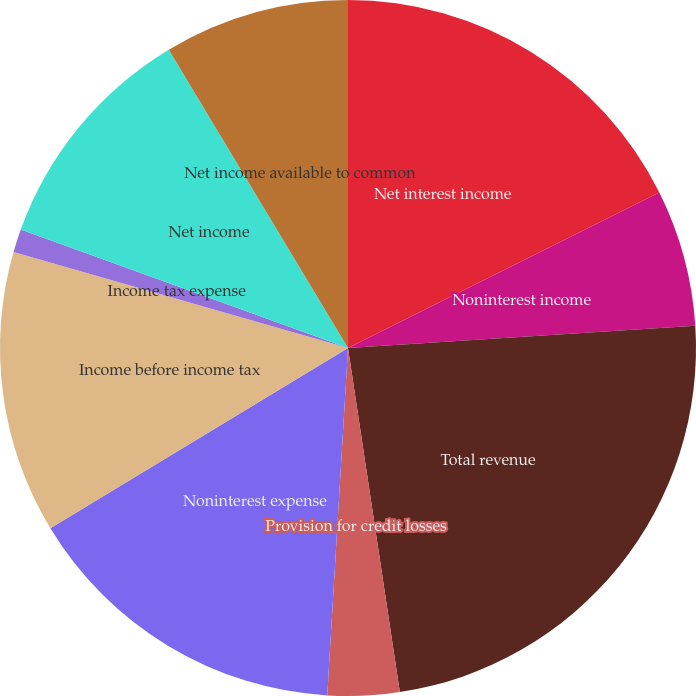<chart> <loc_0><loc_0><loc_500><loc_500><pie_chart><fcel>Net interest income<fcel>Noninterest income<fcel>Total revenue<fcel>Provision for credit losses<fcel>Noninterest expense<fcel>Income before income tax<fcel>Income tax expense<fcel>Net income<fcel>Net income available to common<nl><fcel>17.63%<fcel>6.35%<fcel>23.64%<fcel>3.33%<fcel>15.38%<fcel>13.12%<fcel>1.08%<fcel>10.86%<fcel>8.61%<nl></chart> 